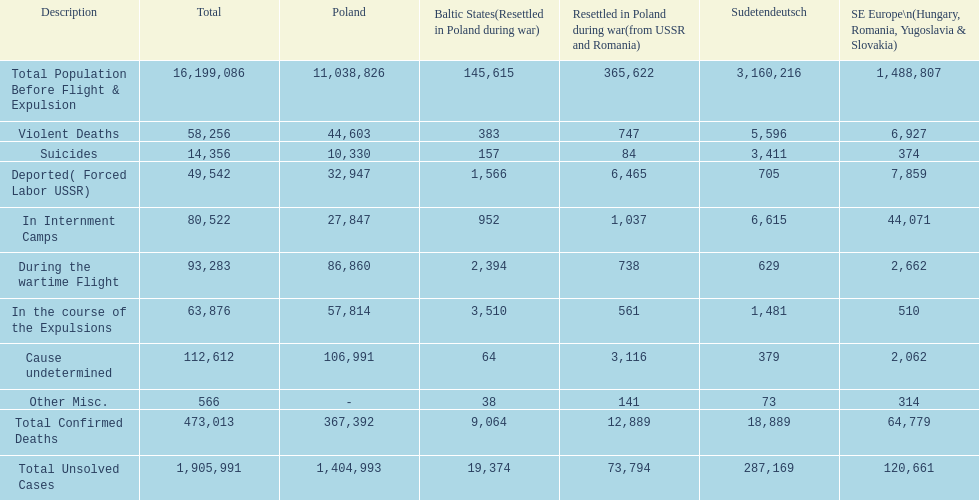Which country experienced a greater number of fatalities? Poland. 